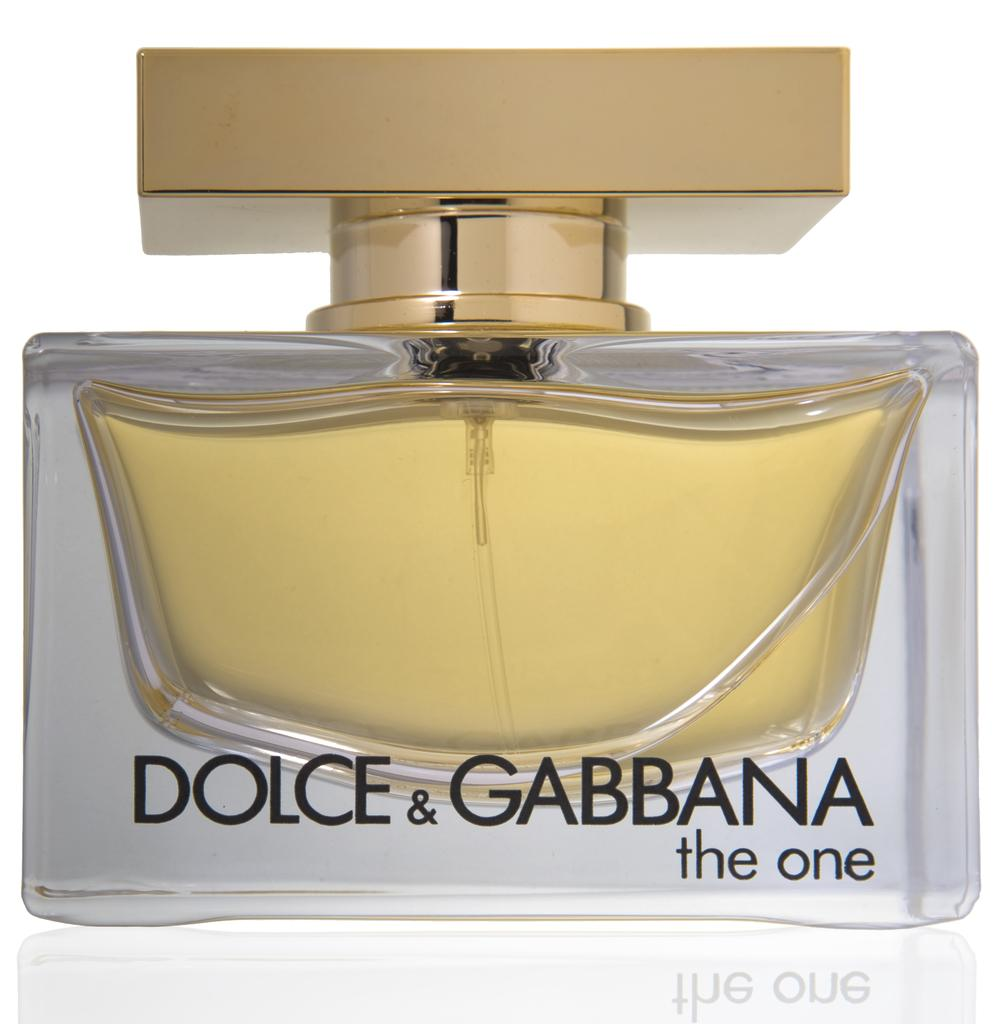<image>
Relay a brief, clear account of the picture shown. A bottle of Dolce & Gabbana perfume called The one. 